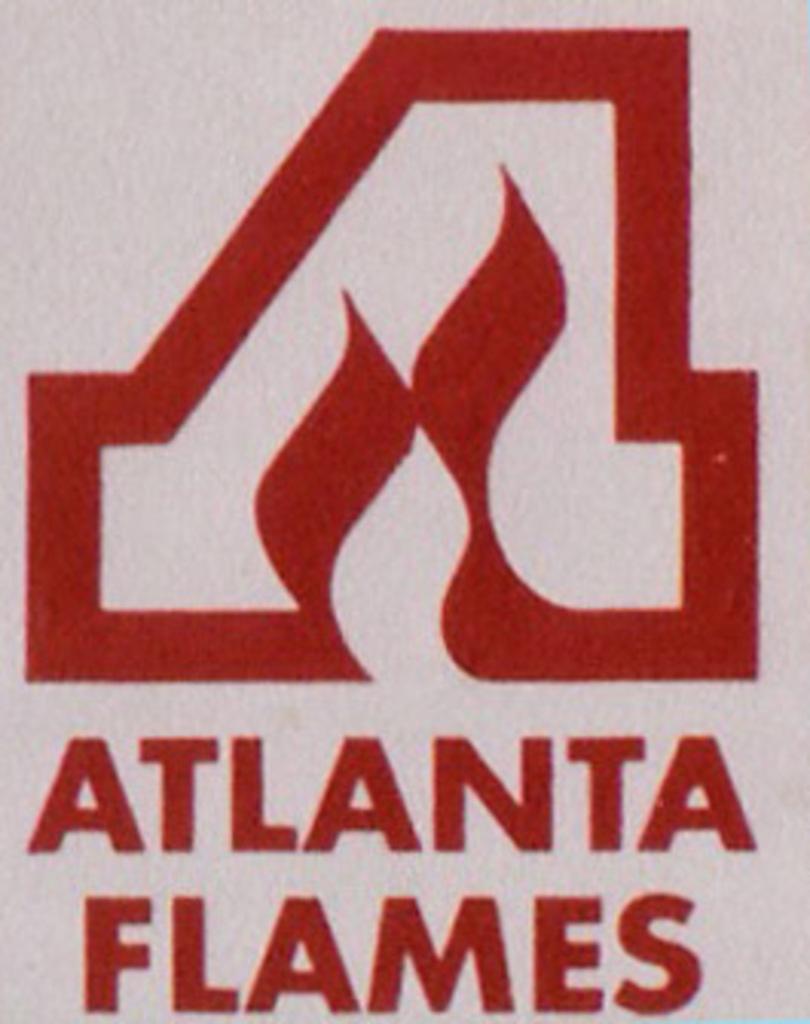What city are the flames from?
Give a very brief answer. Atlanta. 